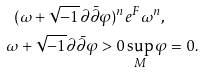Convert formula to latex. <formula><loc_0><loc_0><loc_500><loc_500>( \omega + \sqrt { - 1 } \partial \bar { \partial } \varphi ) ^ { n } & e ^ { F } \omega ^ { n } , \\ \omega + \sqrt { - 1 } \partial \bar { \partial } \varphi > 0 & \sup _ { M } \varphi = 0 .</formula> 